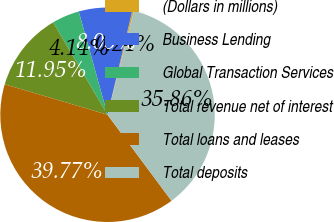Convert chart to OTSL. <chart><loc_0><loc_0><loc_500><loc_500><pie_chart><fcel>(Dollars in millions)<fcel>Business Lending<fcel>Global Transaction Services<fcel>Total revenue net of interest<fcel>Total loans and leases<fcel>Total deposits<nl><fcel>0.24%<fcel>8.05%<fcel>4.14%<fcel>11.95%<fcel>39.77%<fcel>35.86%<nl></chart> 